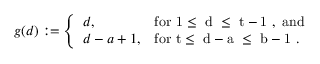<formula> <loc_0><loc_0><loc_500><loc_500>g ( d ) \colon = \left \{ \begin{array} { l l } { d , } & { f o r 1 \leq d \leq t - 1 , a n d } \\ { d - a + 1 , } & { f o r t \leq d - a \leq b - 1 . } \end{array}</formula> 